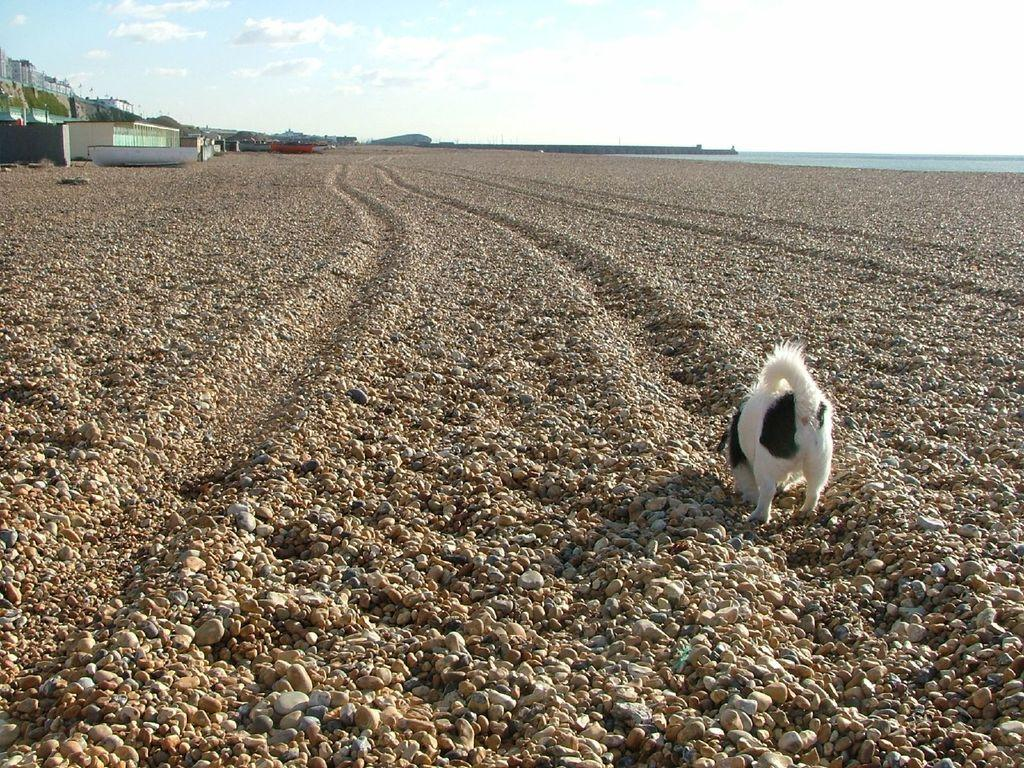What animal can be seen on the rock surface in the image? There is a dog on the rock surface in the image. What type of structure is visible in the background of the image? There is a building in the background of the image. What part of the natural environment is visible in the image? The sky is visible in the background of the image. What type of camera is the dog using to take pictures in the image? There is no camera present in the image, and the dog is not taking pictures. 